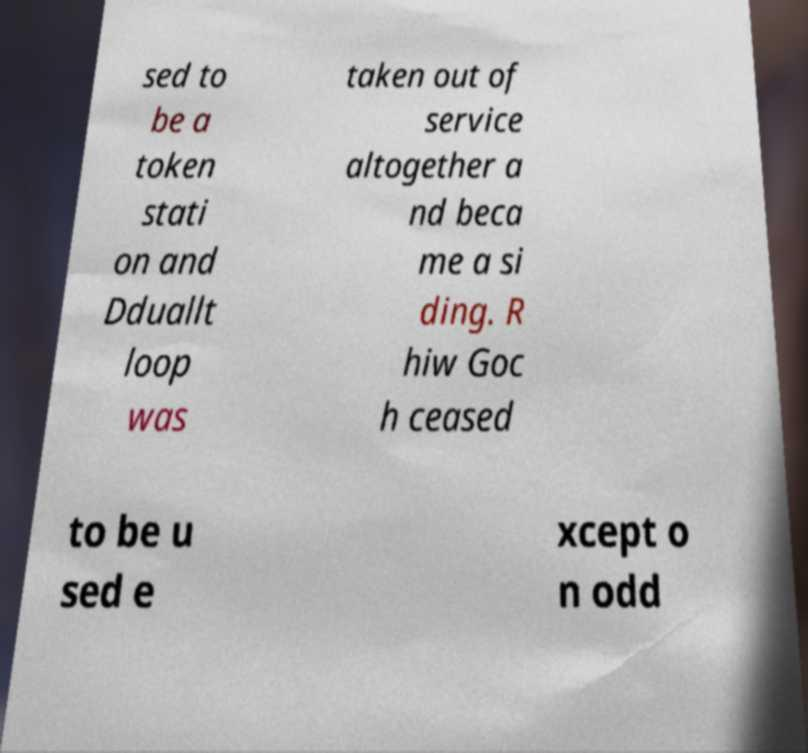For documentation purposes, I need the text within this image transcribed. Could you provide that? sed to be a token stati on and Dduallt loop was taken out of service altogether a nd beca me a si ding. R hiw Goc h ceased to be u sed e xcept o n odd 